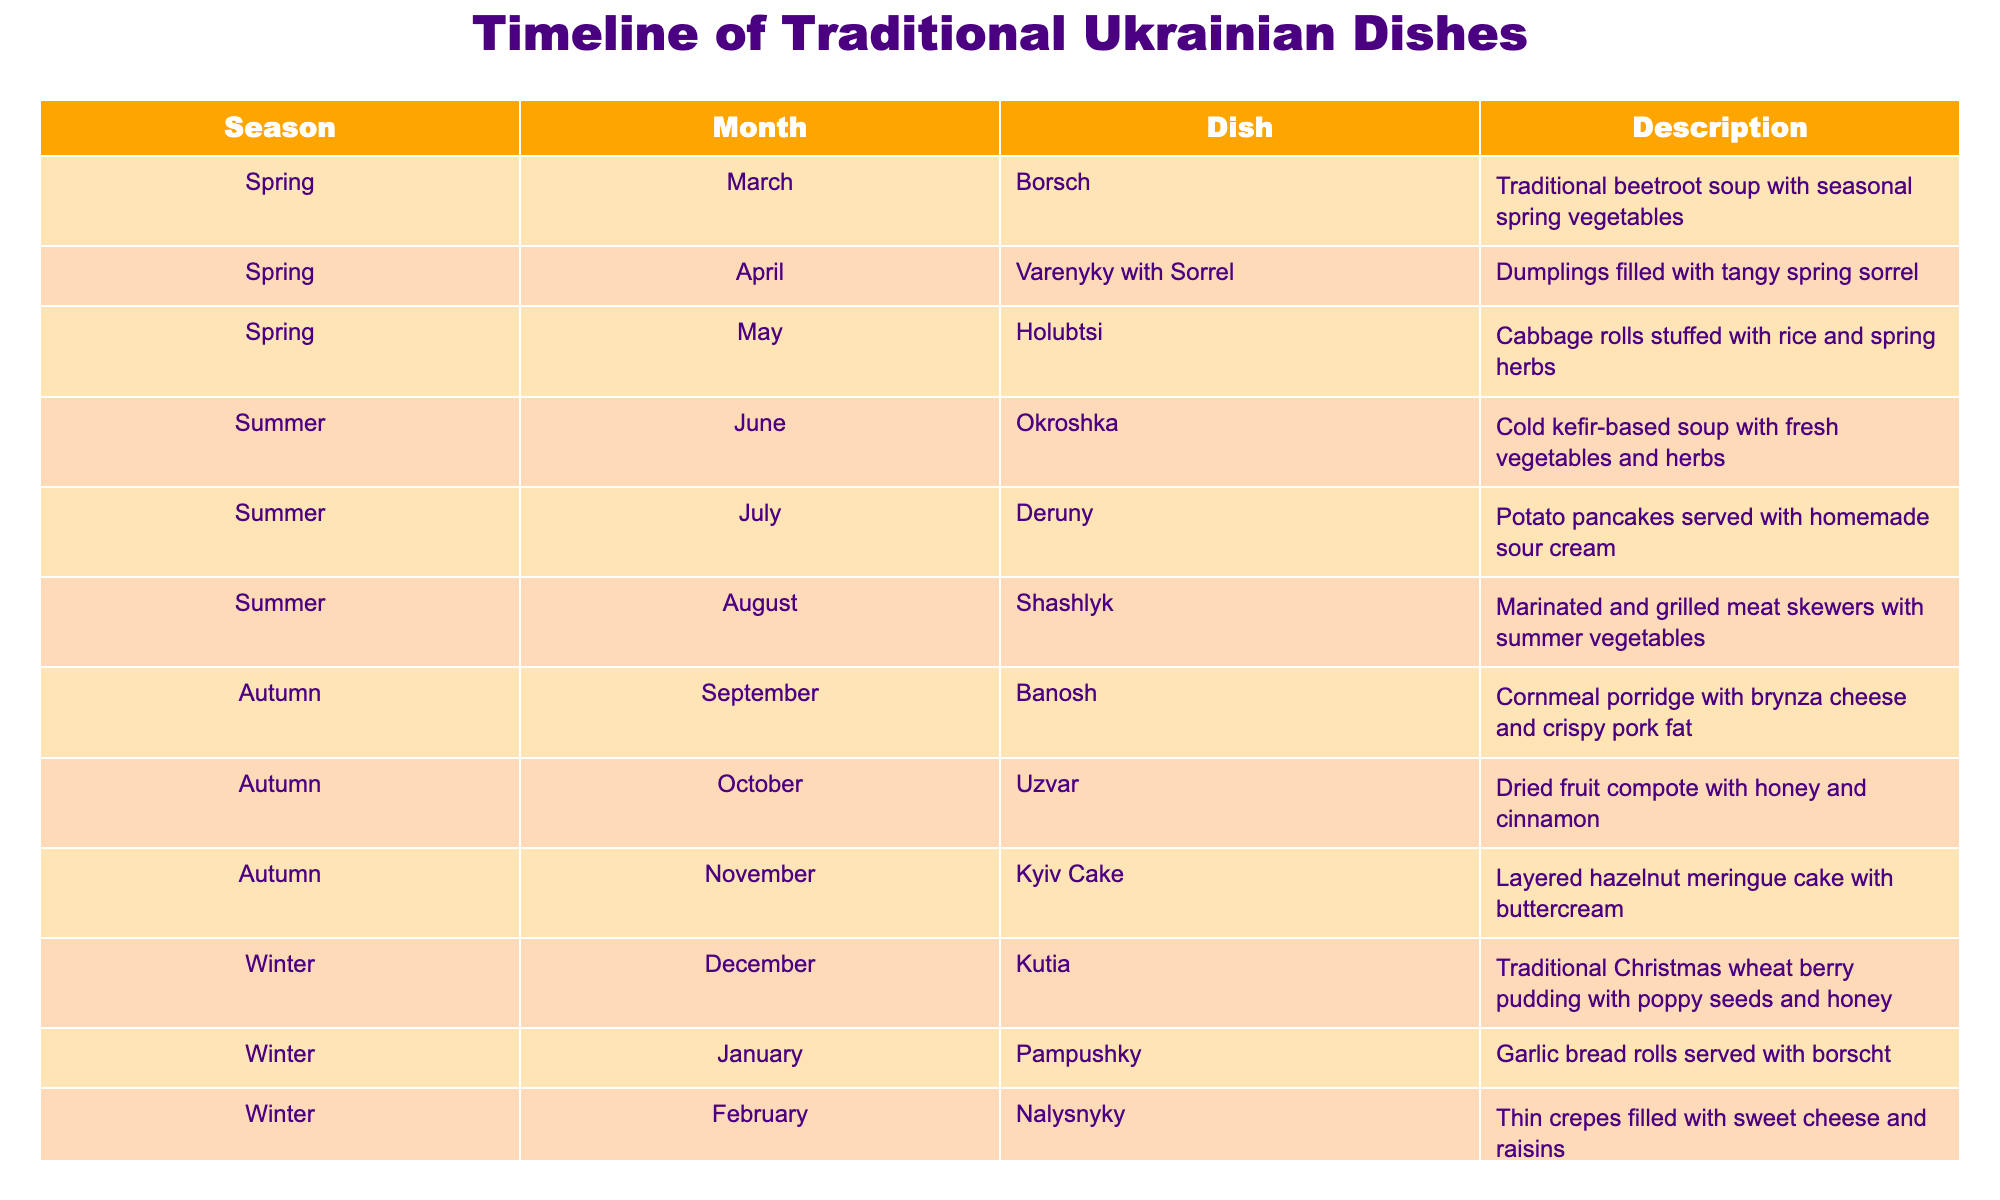What traditional Ukrainian dish is served in June? The table lists the dishes by month. For June, the dish is "Okroshka."
Answer: Okroshka Which month features “Kyiv Cake”? Looking at the table, "Kyiv Cake" is featured in November.
Answer: November How many dishes are featured in the Winter season? The Winter season has three months: December, January, and February. The table lists "Kutia," "Pampushky," and "Nalysnyky" for these months, totaling three dishes.
Answer: Three Is “Varenyky with Sorrel” served in Autumn? According to the table, "Varenyky with Sorrel" is featured in April, which is in Spring, not Autumn.
Answer: No What is the dish served in March and how does it differ from the dish served in May? In March, "Borsch" is served, which is a beetroot soup. In contrast, "Holubtsi," served in May, consists of cabbage rolls stuffed with rice and herbs. Thus, they differ in both preparation and ingredients.
Answer: Borsch; they differ in preparation and ingredients What’s the total number of summer dishes listed? The Summer season includes June, July, and August with "Okroshka," "Deruny," and "Shashlyk" respectively. Therefore, there are three dishes in total for the Summer season.
Answer: Three Are there more dishes from Autumn or Winter in this table? The table shows three dishes for Winter (Kutia, Pampushky, Nalysnyky) and three dishes for Autumn (Banosh, Uzvar, Kyiv Cake). Therefore, they are equal.
Answer: Equal Which dish is typically eaten during Christmas time? Referring to the table, "Kutia" is the dish that is traditionally served during Christmas time in December.
Answer: Kutia What season has the dish that includes garlic bread rolls? The dish "Pampushky," which are garlic bread rolls, is served in January, placing it in the Winter season.
Answer: Winter 